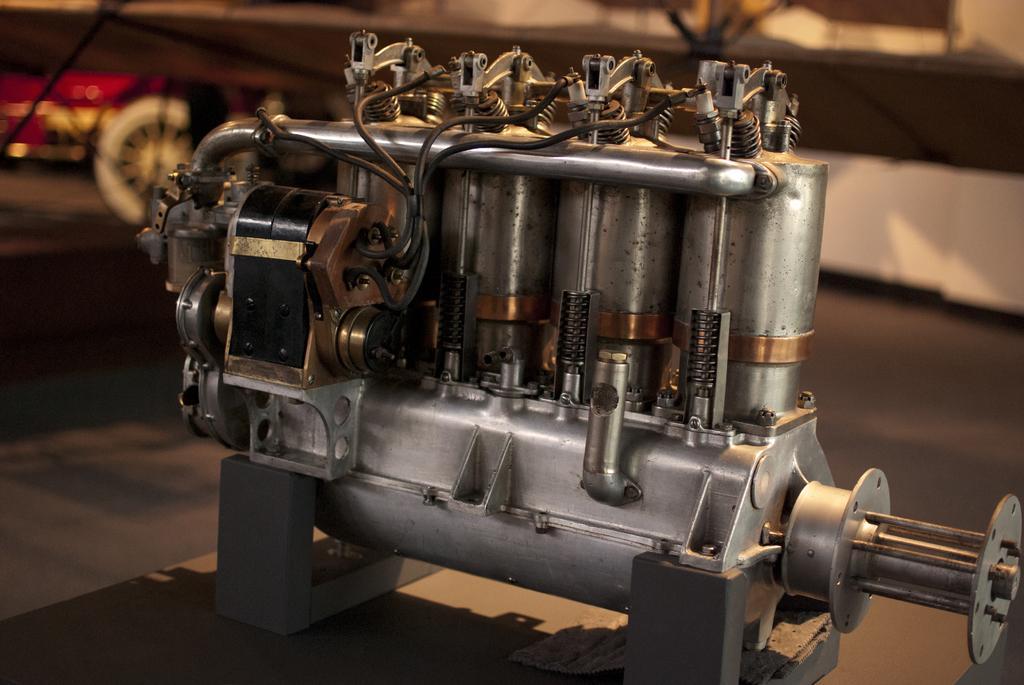Please provide a concise description of this image. In this image we can see there is a machine on the table. 